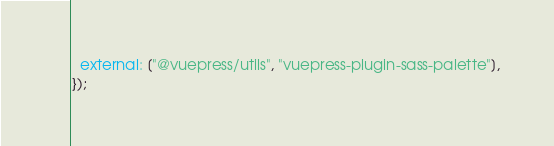<code> <loc_0><loc_0><loc_500><loc_500><_JavaScript_>  external: ["@vuepress/utils", "vuepress-plugin-sass-palette"],
});
</code> 